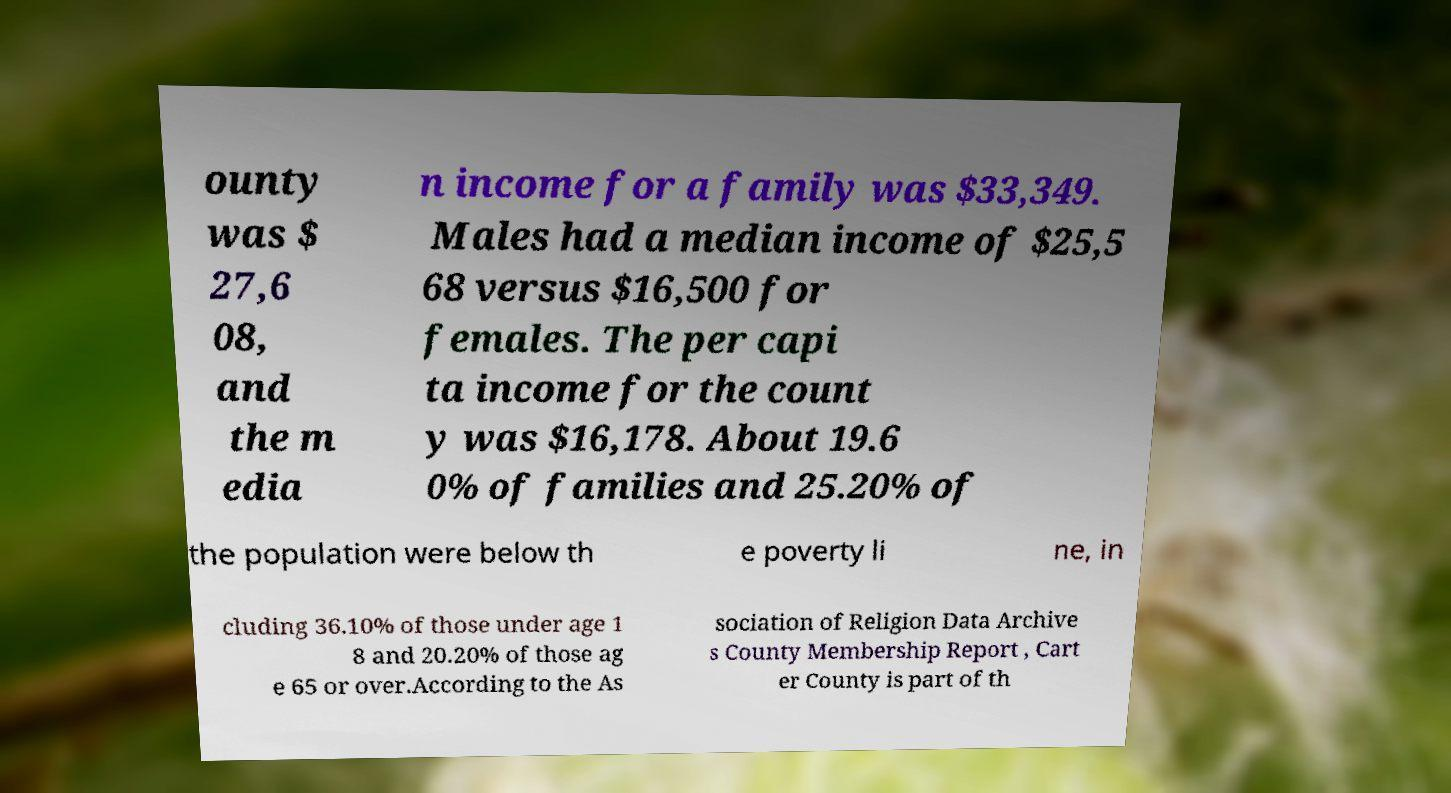I need the written content from this picture converted into text. Can you do that? ounty was $ 27,6 08, and the m edia n income for a family was $33,349. Males had a median income of $25,5 68 versus $16,500 for females. The per capi ta income for the count y was $16,178. About 19.6 0% of families and 25.20% of the population were below th e poverty li ne, in cluding 36.10% of those under age 1 8 and 20.20% of those ag e 65 or over.According to the As sociation of Religion Data Archive s County Membership Report , Cart er County is part of th 